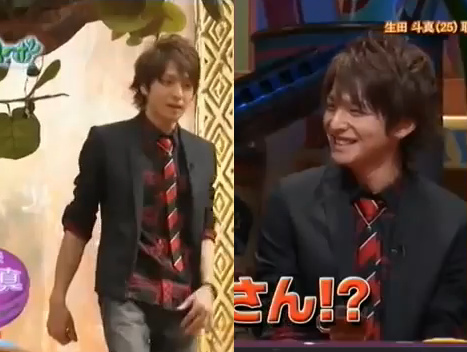Is the young man wearing jeans? Yes, the young man is wearing jeans. 